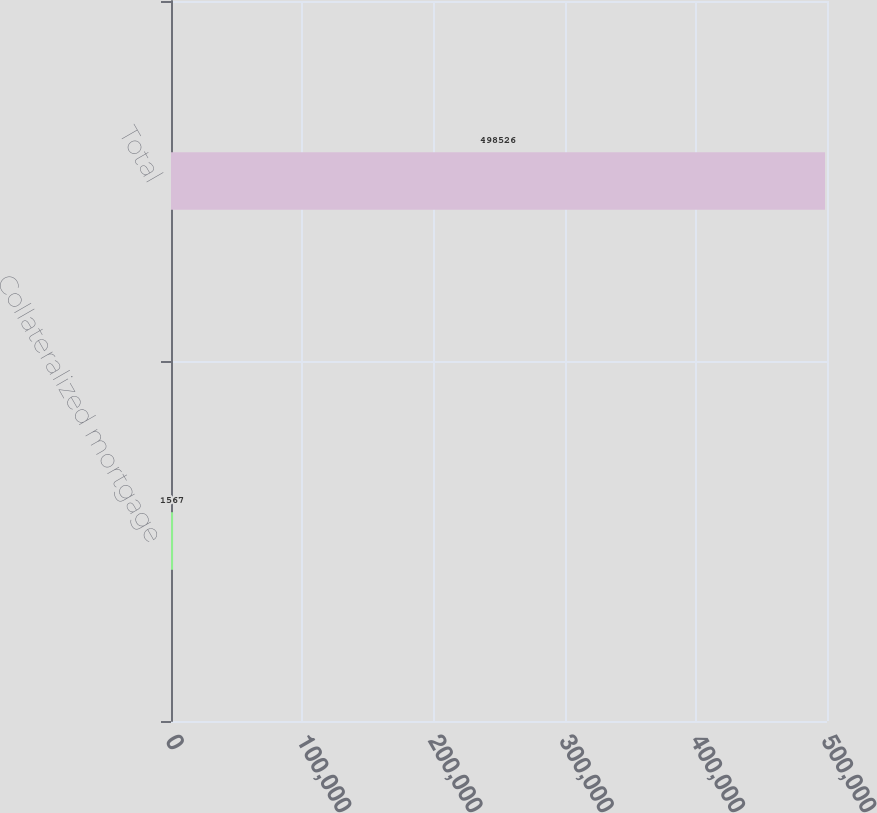Convert chart to OTSL. <chart><loc_0><loc_0><loc_500><loc_500><bar_chart><fcel>Collateralized mortgage<fcel>Total<nl><fcel>1567<fcel>498526<nl></chart> 